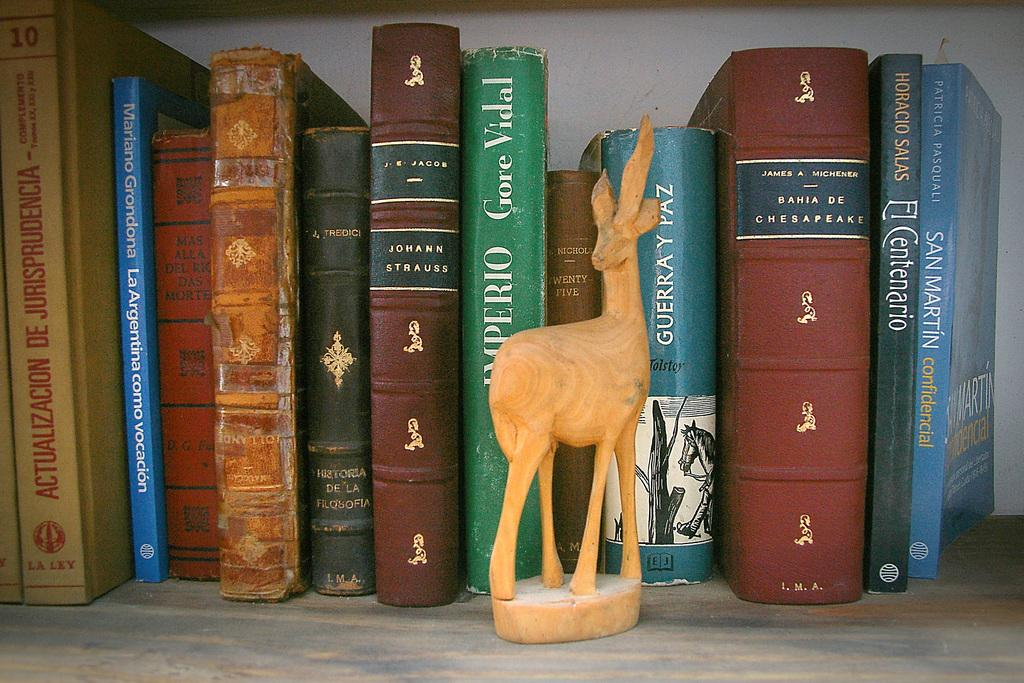<image>
Present a compact description of the photo's key features. Books sit on a bookshelf with San Martin confidencial on the right end. 